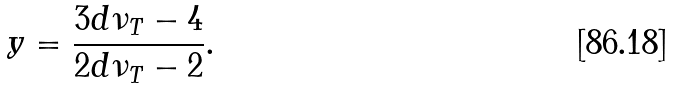Convert formula to latex. <formula><loc_0><loc_0><loc_500><loc_500>y = \frac { 3 d \nu _ { T } - 4 } { 2 d \nu _ { T } - 2 } .</formula> 